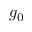Convert formula to latex. <formula><loc_0><loc_0><loc_500><loc_500>g _ { 0 }</formula> 